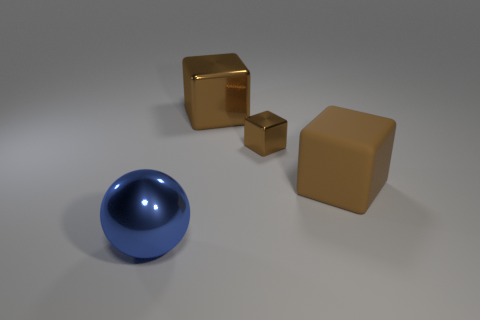There is a big cube behind the large brown matte object; what color is it?
Provide a short and direct response. Brown. What number of rubber things are either small blue cylinders or large balls?
Give a very brief answer. 0. What material is the large thing that is left of the large block behind the matte thing?
Your answer should be compact. Metal. There is a small object that is the same color as the big matte object; what is its material?
Offer a terse response. Metal. The big metallic block is what color?
Provide a short and direct response. Brown. Are there any big cubes right of the large matte object in front of the large metal cube?
Provide a short and direct response. No. What material is the ball?
Offer a very short reply. Metal. Does the large sphere in front of the small metal block have the same material as the big brown thing left of the large brown matte thing?
Provide a succinct answer. Yes. Is there any other thing of the same color as the large sphere?
Give a very brief answer. No. What is the color of the other metal thing that is the same shape as the large brown metal object?
Offer a very short reply. Brown. 